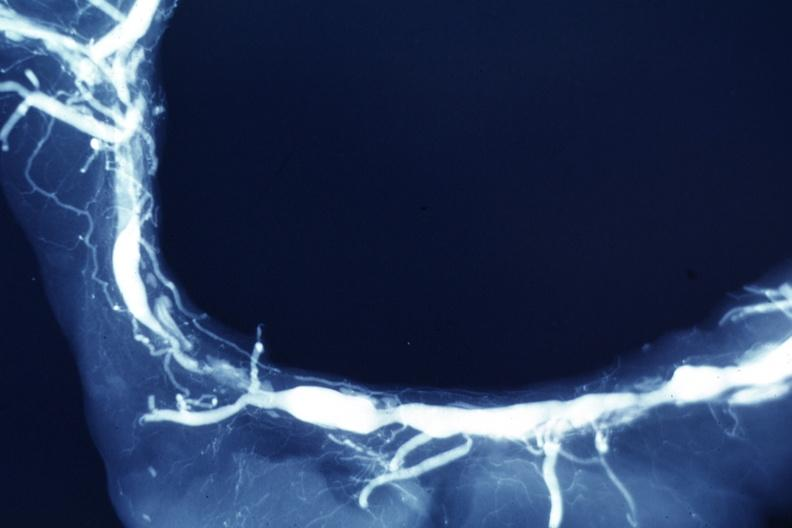what is present?
Answer the question using a single word or phrase. Coronary artery 